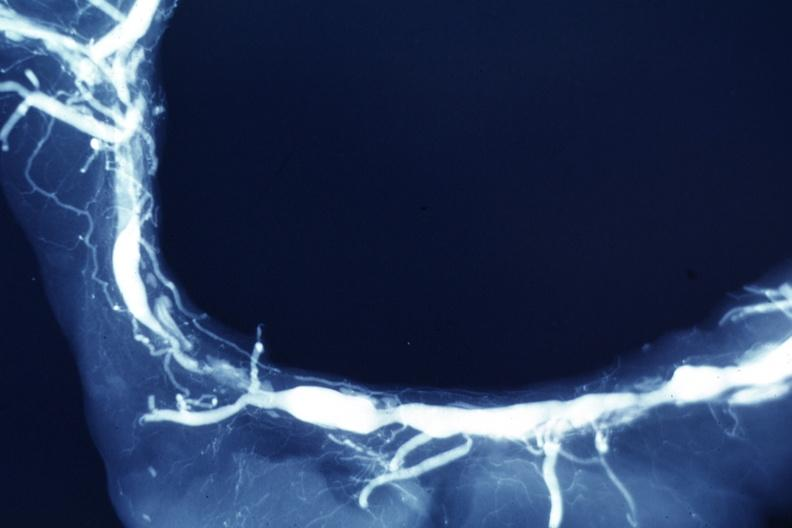what is present?
Answer the question using a single word or phrase. Coronary artery 